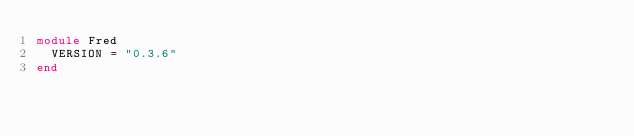<code> <loc_0><loc_0><loc_500><loc_500><_Crystal_>module Fred
  VERSION = "0.3.6"
end
</code> 